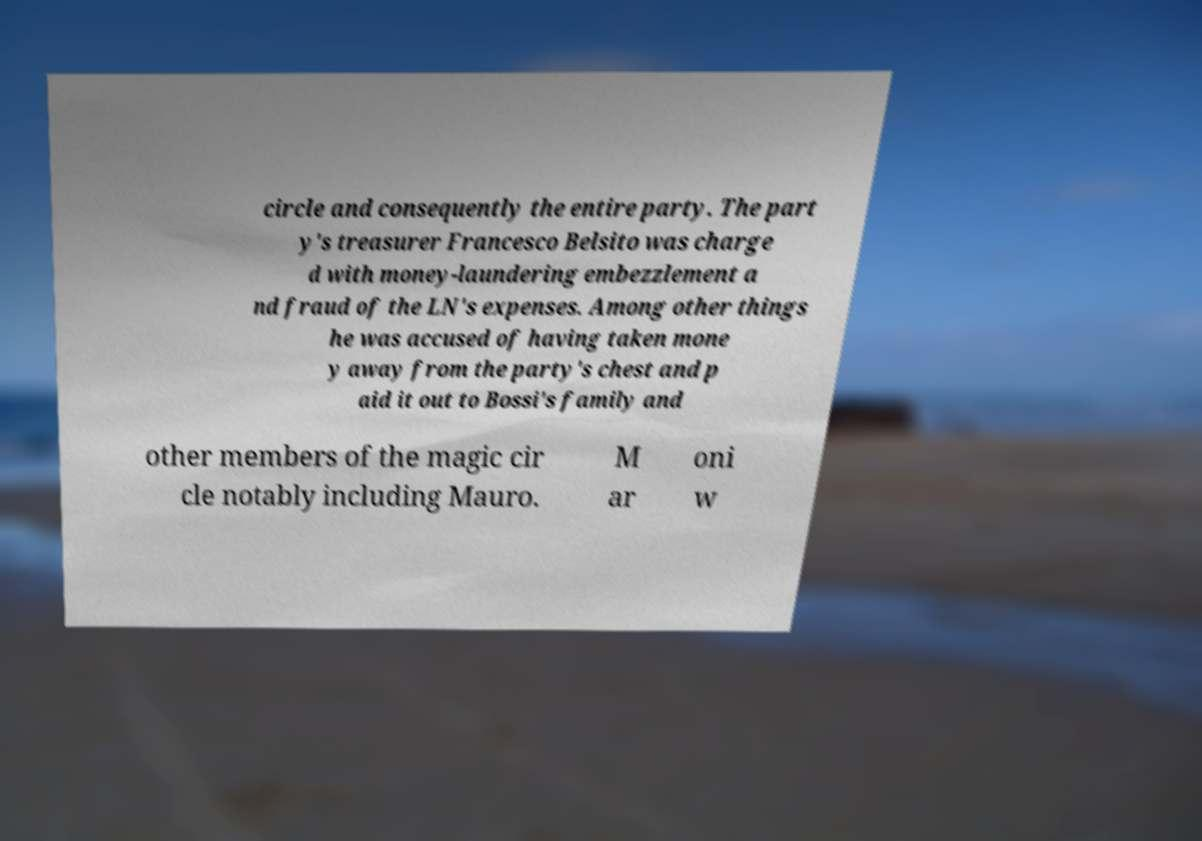What messages or text are displayed in this image? I need them in a readable, typed format. circle and consequently the entire party. The part y's treasurer Francesco Belsito was charge d with money-laundering embezzlement a nd fraud of the LN's expenses. Among other things he was accused of having taken mone y away from the party's chest and p aid it out to Bossi's family and other members of the magic cir cle notably including Mauro. M ar oni w 